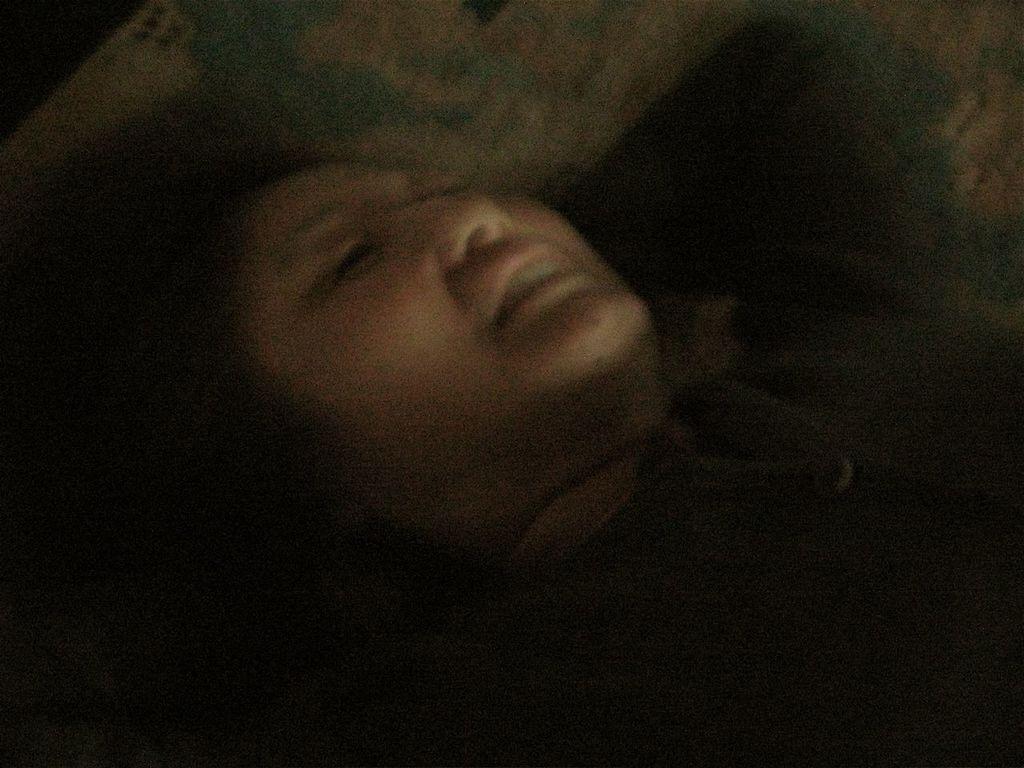In one or two sentences, can you explain what this image depicts? Here in this picture we can see a woman laying on a bed, on a place over there. 